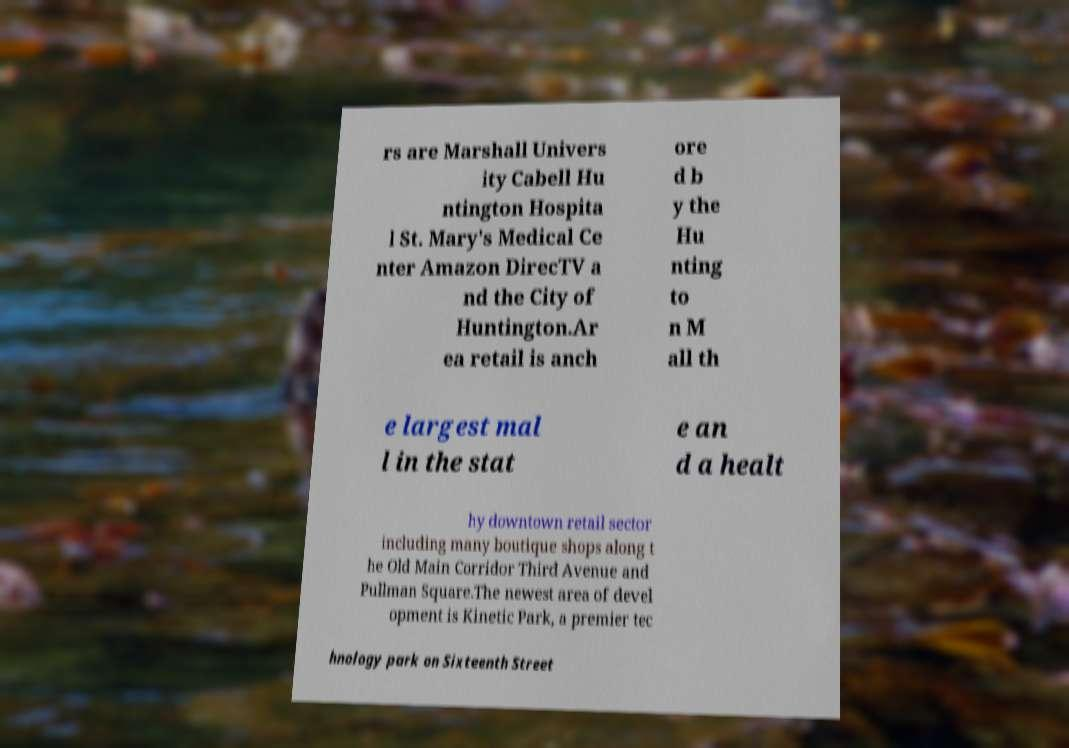I need the written content from this picture converted into text. Can you do that? rs are Marshall Univers ity Cabell Hu ntington Hospita l St. Mary's Medical Ce nter Amazon DirecTV a nd the City of Huntington.Ar ea retail is anch ore d b y the Hu nting to n M all th e largest mal l in the stat e an d a healt hy downtown retail sector including many boutique shops along t he Old Main Corridor Third Avenue and Pullman Square.The newest area of devel opment is Kinetic Park, a premier tec hnology park on Sixteenth Street 